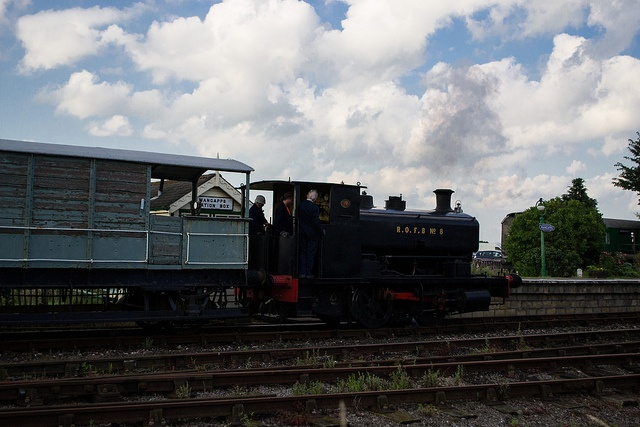Describe the objects in this image and their specific colors. I can see train in lightgray, black, purple, gray, and darkblue tones, people in lightgray, black, gray, and maroon tones, people in lightgray, black, maroon, and brown tones, and people in lightgray, black, gray, darkgray, and maroon tones in this image. 